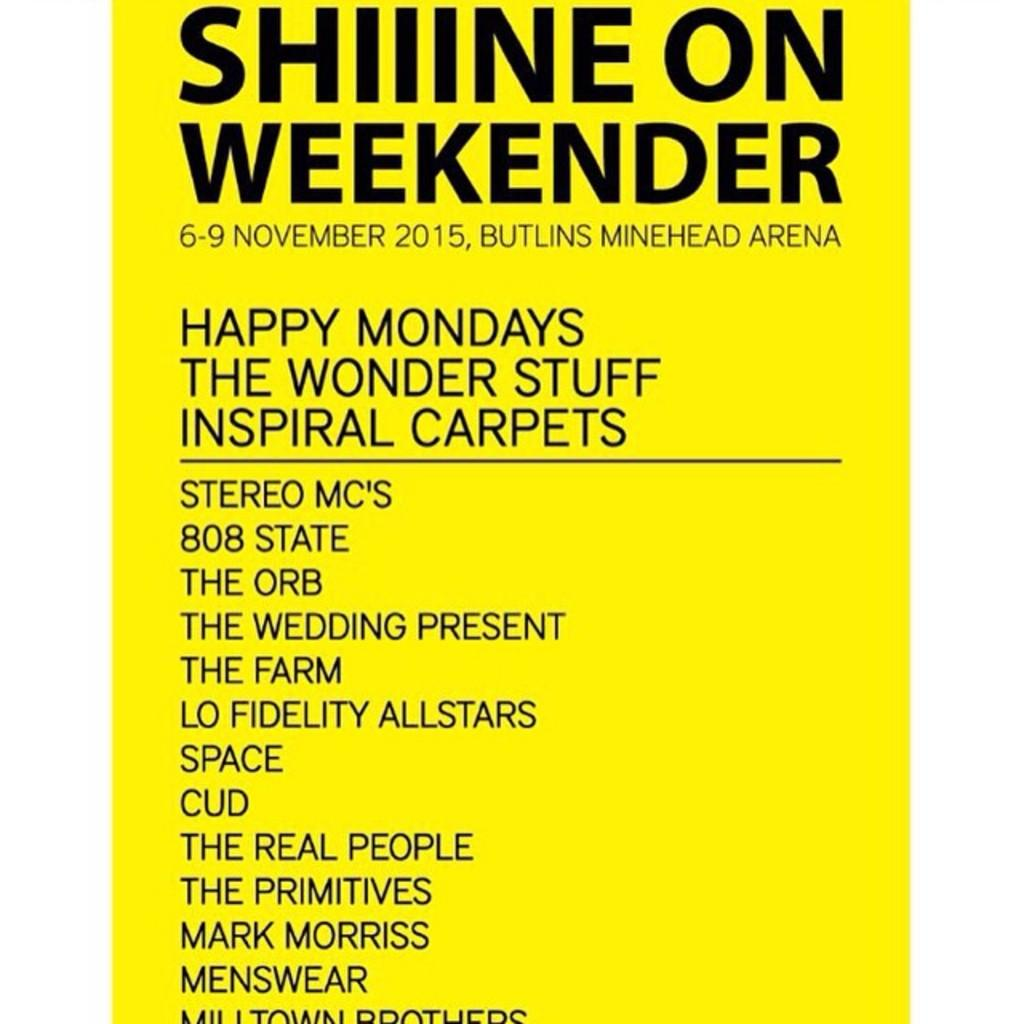<image>
Provide a brief description of the given image. a poster telling happy mondays the wonder stuff 